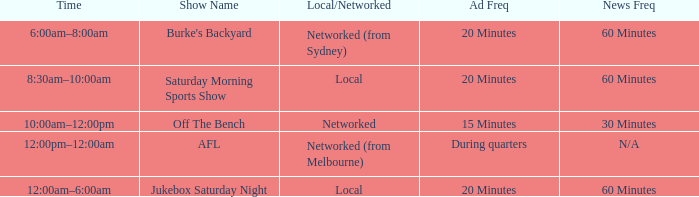What is the ad frequency for the Show Off The Bench? 15 Minutes. 